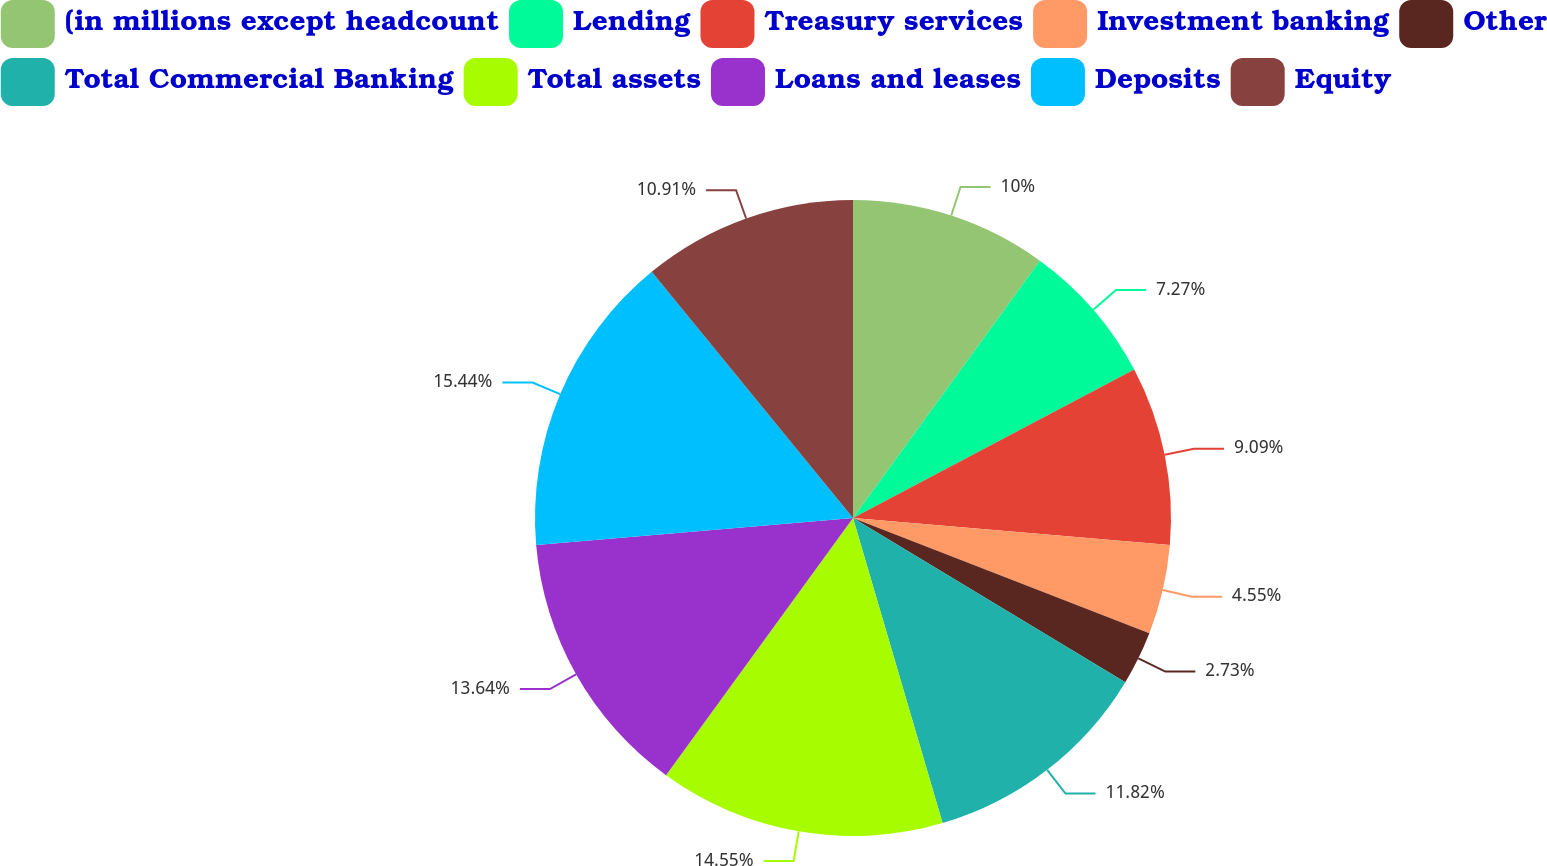<chart> <loc_0><loc_0><loc_500><loc_500><pie_chart><fcel>(in millions except headcount<fcel>Lending<fcel>Treasury services<fcel>Investment banking<fcel>Other<fcel>Total Commercial Banking<fcel>Total assets<fcel>Loans and leases<fcel>Deposits<fcel>Equity<nl><fcel>10.0%<fcel>7.27%<fcel>9.09%<fcel>4.55%<fcel>2.73%<fcel>11.82%<fcel>14.55%<fcel>13.64%<fcel>15.45%<fcel>10.91%<nl></chart> 